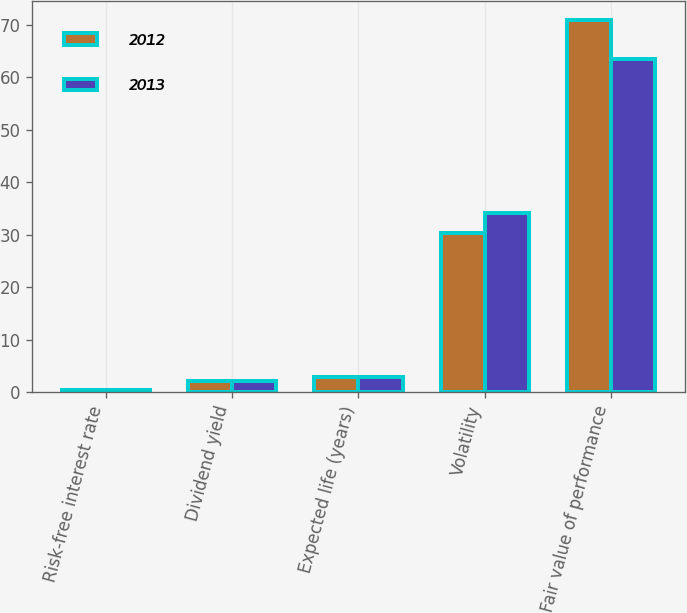<chart> <loc_0><loc_0><loc_500><loc_500><stacked_bar_chart><ecel><fcel>Risk-free interest rate<fcel>Dividend yield<fcel>Expected life (years)<fcel>Volatility<fcel>Fair value of performance<nl><fcel>2012<fcel>0.4<fcel>2.06<fcel>2.9<fcel>30.36<fcel>70.92<nl><fcel>2013<fcel>0.37<fcel>2.03<fcel>2.9<fcel>34.1<fcel>63.43<nl></chart> 